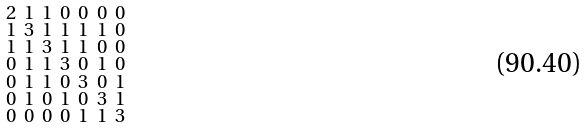Convert formula to latex. <formula><loc_0><loc_0><loc_500><loc_500>\begin{smallmatrix} 2 & 1 & 1 & 0 & 0 & 0 & 0 \\ 1 & 3 & 1 & 1 & 1 & 1 & 0 \\ 1 & 1 & 3 & 1 & 1 & 0 & 0 \\ 0 & 1 & 1 & 3 & 0 & 1 & 0 \\ 0 & 1 & 1 & 0 & 3 & 0 & 1 \\ 0 & 1 & 0 & 1 & 0 & 3 & 1 \\ 0 & 0 & 0 & 0 & 1 & 1 & 3 \end{smallmatrix}</formula> 